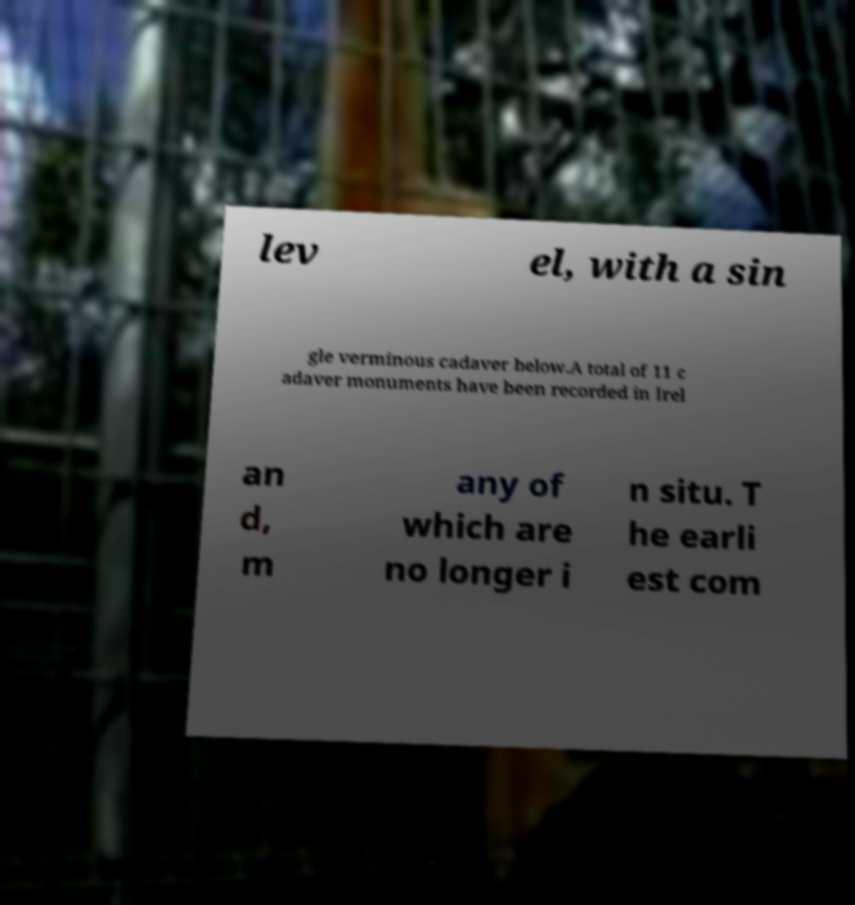Please read and relay the text visible in this image. What does it say? lev el, with a sin gle verminous cadaver below.A total of 11 c adaver monuments have been recorded in Irel an d, m any of which are no longer i n situ. T he earli est com 